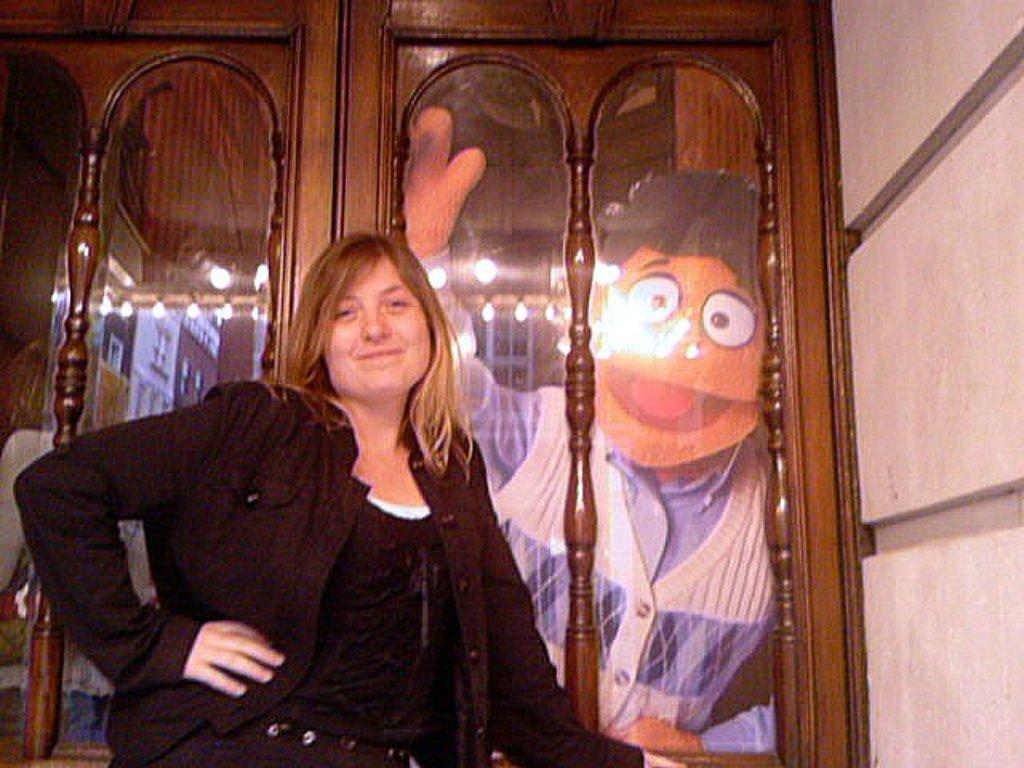Who is the main subject in the image? There is a woman in the image. Can you describe the woman's appearance? The woman has long hair and is wearing a black dress. What is the woman standing in front of? The woman is standing in front of a cupboard. What can be seen inside the cupboard? There is a photo of a person in the cupboard. What type of laborer is working in the background of the image? There is no laborer present in the image, and therefore no such activity can be observed. What is the woman learning in the image? The image does not provide any information about the woman learning anything. 